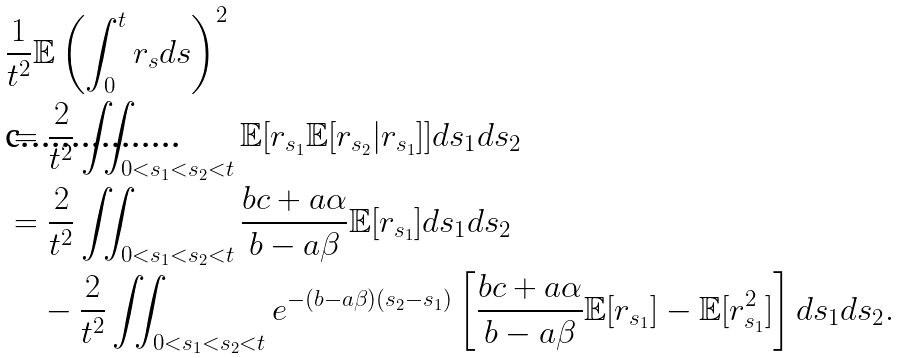Convert formula to latex. <formula><loc_0><loc_0><loc_500><loc_500>& \frac { 1 } { t ^ { 2 } } \mathbb { E } \left ( \int _ { 0 } ^ { t } r _ { s } d s \right ) ^ { 2 } \\ & = \frac { 2 } { t ^ { 2 } } \iint _ { 0 < s _ { 1 } < s _ { 2 } < t } \mathbb { E } [ r _ { s _ { 1 } } \mathbb { E } [ r _ { s _ { 2 } } | r _ { s _ { 1 } } ] ] d s _ { 1 } d s _ { 2 } \\ & = \frac { 2 } { t ^ { 2 } } \iint _ { 0 < s _ { 1 } < s _ { 2 } < t } \frac { b c + a \alpha } { b - a \beta } \mathbb { E } [ r _ { s _ { 1 } } ] d s _ { 1 } d s _ { 2 } \\ & \quad - \frac { 2 } { t ^ { 2 } } \iint _ { 0 < s _ { 1 } < s _ { 2 } < t } e ^ { - ( b - a \beta ) ( s _ { 2 } - s _ { 1 } ) } \left [ \frac { b c + a \alpha } { b - a \beta } \mathbb { E } [ r _ { s _ { 1 } } ] - \mathbb { E } [ r _ { s _ { 1 } } ^ { 2 } ] \right ] d s _ { 1 } d s _ { 2 } .</formula> 